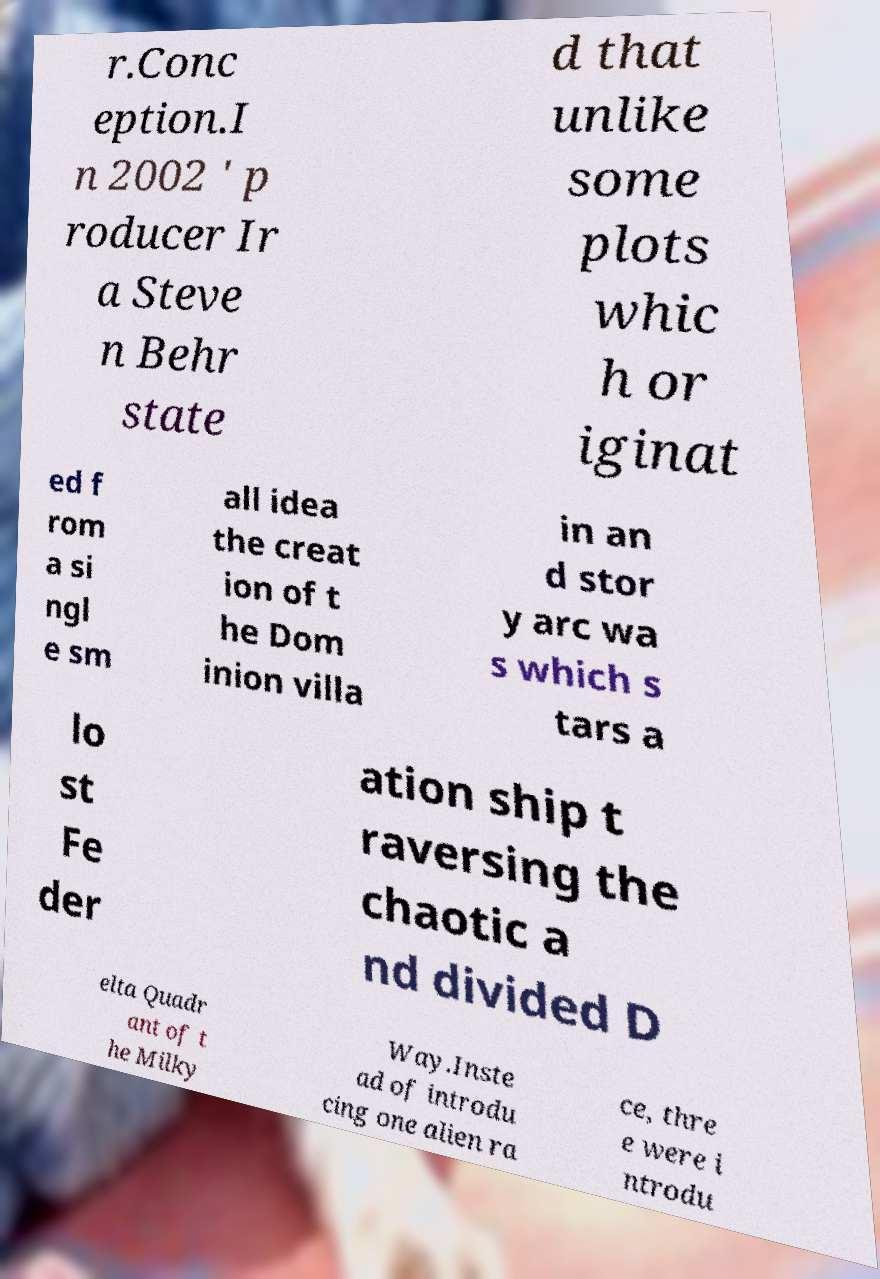Please identify and transcribe the text found in this image. r.Conc eption.I n 2002 ' p roducer Ir a Steve n Behr state d that unlike some plots whic h or iginat ed f rom a si ngl e sm all idea the creat ion of t he Dom inion villa in an d stor y arc wa s which s tars a lo st Fe der ation ship t raversing the chaotic a nd divided D elta Quadr ant of t he Milky Way.Inste ad of introdu cing one alien ra ce, thre e were i ntrodu 